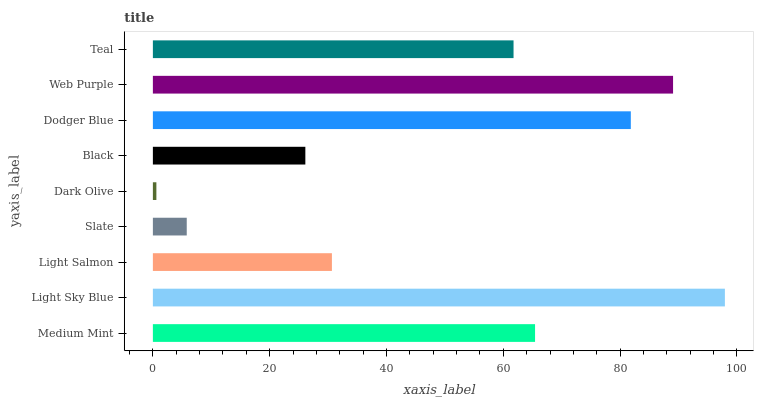Is Dark Olive the minimum?
Answer yes or no. Yes. Is Light Sky Blue the maximum?
Answer yes or no. Yes. Is Light Salmon the minimum?
Answer yes or no. No. Is Light Salmon the maximum?
Answer yes or no. No. Is Light Sky Blue greater than Light Salmon?
Answer yes or no. Yes. Is Light Salmon less than Light Sky Blue?
Answer yes or no. Yes. Is Light Salmon greater than Light Sky Blue?
Answer yes or no. No. Is Light Sky Blue less than Light Salmon?
Answer yes or no. No. Is Teal the high median?
Answer yes or no. Yes. Is Teal the low median?
Answer yes or no. Yes. Is Slate the high median?
Answer yes or no. No. Is Medium Mint the low median?
Answer yes or no. No. 